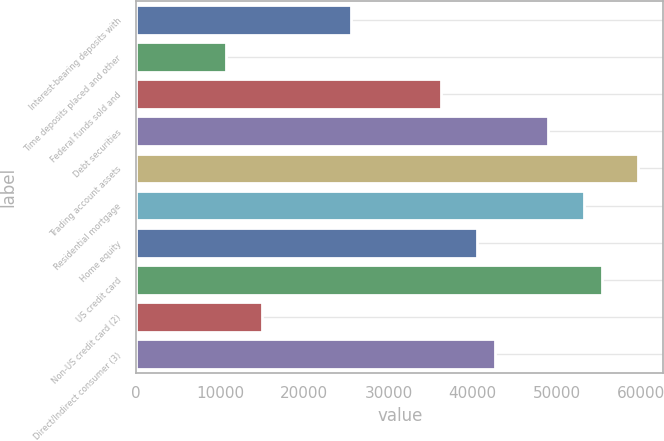Convert chart to OTSL. <chart><loc_0><loc_0><loc_500><loc_500><bar_chart><fcel>Interest-bearing deposits with<fcel>Time deposits placed and other<fcel>Federal funds sold and<fcel>Debt securities<fcel>Trading account assets<fcel>Residential mortgage<fcel>Home equity<fcel>US credit card<fcel>Non-US credit card (2)<fcel>Direct/Indirect consumer (3)<nl><fcel>25585.4<fcel>10663.5<fcel>36243.9<fcel>49034.1<fcel>59692.6<fcel>53297.5<fcel>40507.3<fcel>55429.2<fcel>14926.9<fcel>42639<nl></chart> 